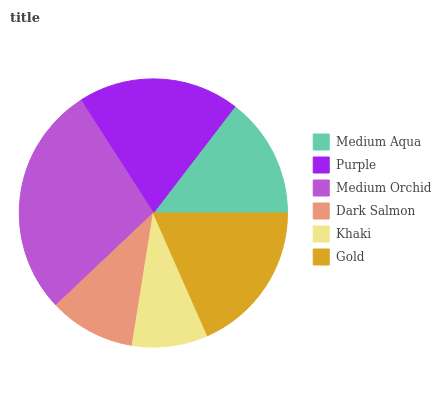Is Khaki the minimum?
Answer yes or no. Yes. Is Medium Orchid the maximum?
Answer yes or no. Yes. Is Purple the minimum?
Answer yes or no. No. Is Purple the maximum?
Answer yes or no. No. Is Purple greater than Medium Aqua?
Answer yes or no. Yes. Is Medium Aqua less than Purple?
Answer yes or no. Yes. Is Medium Aqua greater than Purple?
Answer yes or no. No. Is Purple less than Medium Aqua?
Answer yes or no. No. Is Gold the high median?
Answer yes or no. Yes. Is Medium Aqua the low median?
Answer yes or no. Yes. Is Medium Aqua the high median?
Answer yes or no. No. Is Gold the low median?
Answer yes or no. No. 